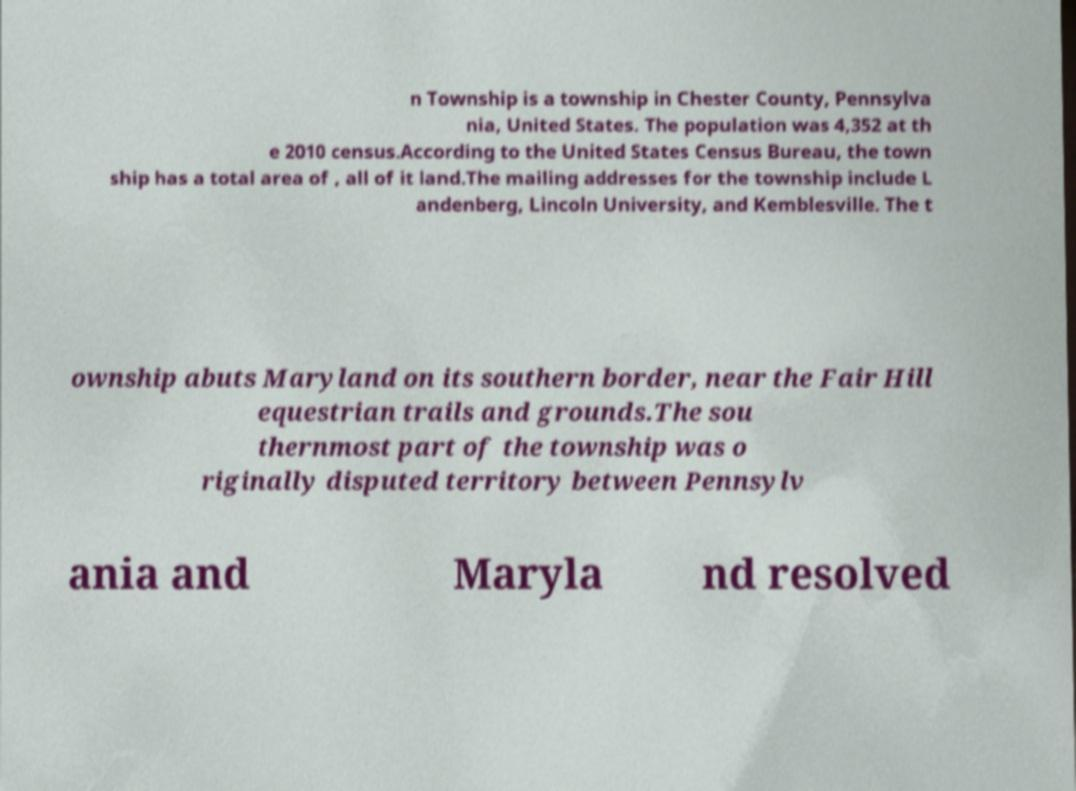Could you extract and type out the text from this image? n Township is a township in Chester County, Pennsylva nia, United States. The population was 4,352 at th e 2010 census.According to the United States Census Bureau, the town ship has a total area of , all of it land.The mailing addresses for the township include L andenberg, Lincoln University, and Kemblesville. The t ownship abuts Maryland on its southern border, near the Fair Hill equestrian trails and grounds.The sou thernmost part of the township was o riginally disputed territory between Pennsylv ania and Maryla nd resolved 